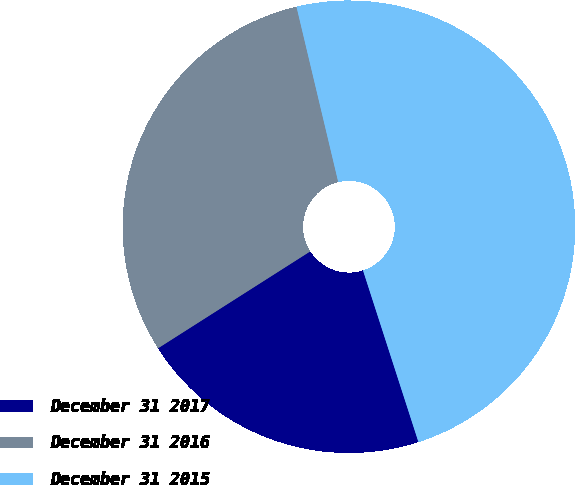<chart> <loc_0><loc_0><loc_500><loc_500><pie_chart><fcel>December 31 2017<fcel>December 31 2016<fcel>December 31 2015<nl><fcel>20.95%<fcel>30.3%<fcel>48.75%<nl></chart> 